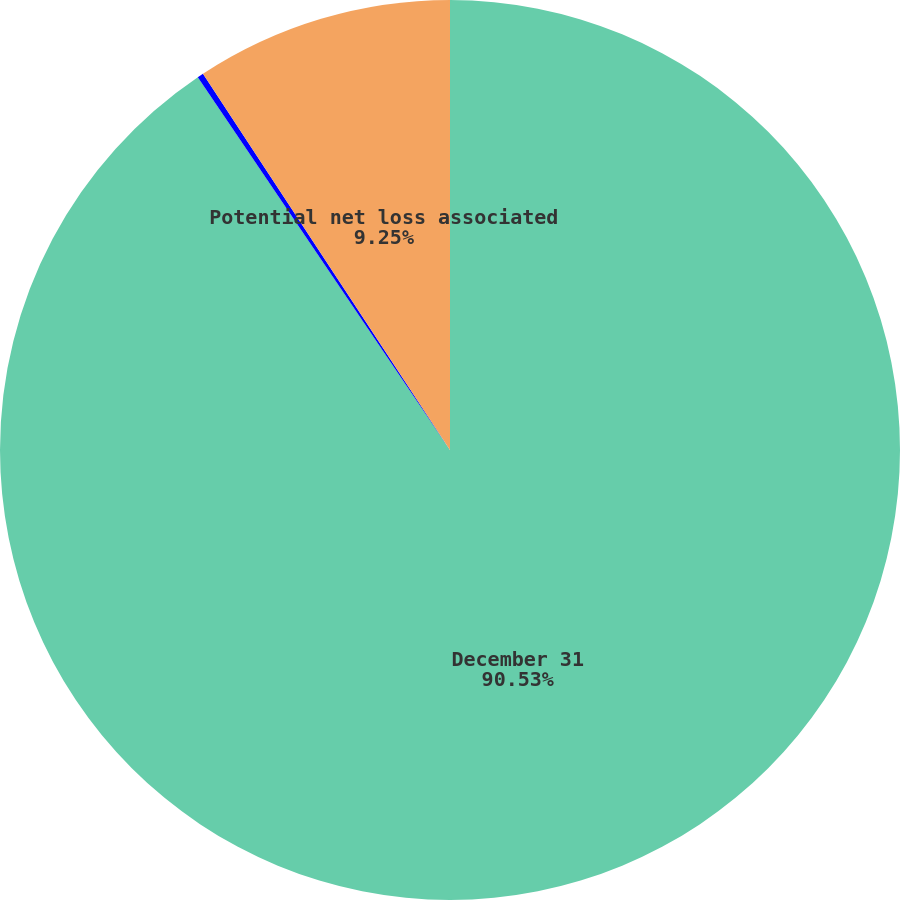<chart> <loc_0><loc_0><loc_500><loc_500><pie_chart><fcel>December 31<fcel>Fair value of foreign exchange<fcel>Potential net loss associated<nl><fcel>90.54%<fcel>0.22%<fcel>9.25%<nl></chart> 